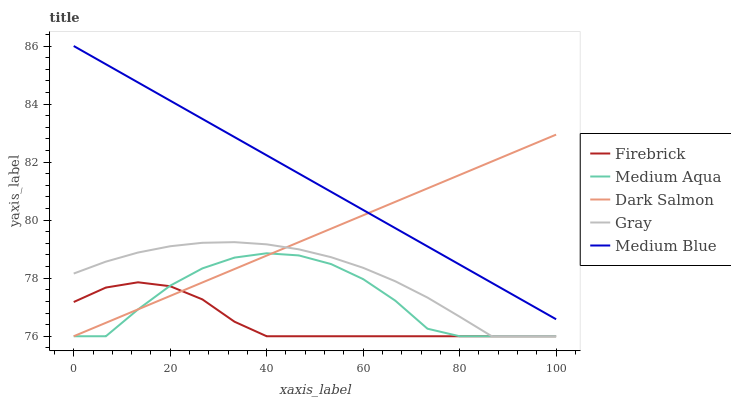Does Firebrick have the minimum area under the curve?
Answer yes or no. Yes. Does Medium Blue have the maximum area under the curve?
Answer yes or no. Yes. Does Gray have the minimum area under the curve?
Answer yes or no. No. Does Gray have the maximum area under the curve?
Answer yes or no. No. Is Medium Blue the smoothest?
Answer yes or no. Yes. Is Medium Aqua the roughest?
Answer yes or no. Yes. Is Gray the smoothest?
Answer yes or no. No. Is Gray the roughest?
Answer yes or no. No. Does Gray have the lowest value?
Answer yes or no. Yes. Does Medium Blue have the highest value?
Answer yes or no. Yes. Does Gray have the highest value?
Answer yes or no. No. Is Medium Aqua less than Medium Blue?
Answer yes or no. Yes. Is Medium Blue greater than Gray?
Answer yes or no. Yes. Does Gray intersect Medium Aqua?
Answer yes or no. Yes. Is Gray less than Medium Aqua?
Answer yes or no. No. Is Gray greater than Medium Aqua?
Answer yes or no. No. Does Medium Aqua intersect Medium Blue?
Answer yes or no. No. 